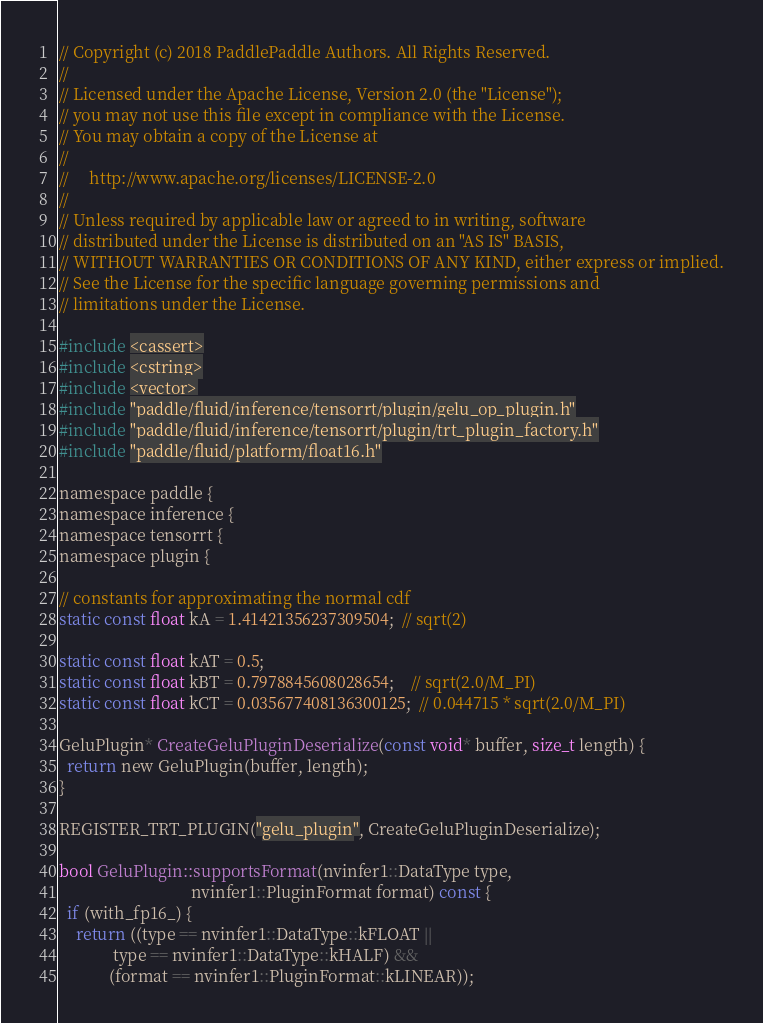Convert code to text. <code><loc_0><loc_0><loc_500><loc_500><_Cuda_>// Copyright (c) 2018 PaddlePaddle Authors. All Rights Reserved.
//
// Licensed under the Apache License, Version 2.0 (the "License");
// you may not use this file except in compliance with the License.
// You may obtain a copy of the License at
//
//     http://www.apache.org/licenses/LICENSE-2.0
//
// Unless required by applicable law or agreed to in writing, software
// distributed under the License is distributed on an "AS IS" BASIS,
// WITHOUT WARRANTIES OR CONDITIONS OF ANY KIND, either express or implied.
// See the License for the specific language governing permissions and
// limitations under the License.

#include <cassert>
#include <cstring>
#include <vector>
#include "paddle/fluid/inference/tensorrt/plugin/gelu_op_plugin.h"
#include "paddle/fluid/inference/tensorrt/plugin/trt_plugin_factory.h"
#include "paddle/fluid/platform/float16.h"

namespace paddle {
namespace inference {
namespace tensorrt {
namespace plugin {

// constants for approximating the normal cdf
static const float kA = 1.41421356237309504;  // sqrt(2)

static const float kAT = 0.5;
static const float kBT = 0.7978845608028654;    // sqrt(2.0/M_PI)
static const float kCT = 0.035677408136300125;  // 0.044715 * sqrt(2.0/M_PI)

GeluPlugin* CreateGeluPluginDeserialize(const void* buffer, size_t length) {
  return new GeluPlugin(buffer, length);
}

REGISTER_TRT_PLUGIN("gelu_plugin", CreateGeluPluginDeserialize);

bool GeluPlugin::supportsFormat(nvinfer1::DataType type,
                                nvinfer1::PluginFormat format) const {
  if (with_fp16_) {
    return ((type == nvinfer1::DataType::kFLOAT ||
             type == nvinfer1::DataType::kHALF) &&
            (format == nvinfer1::PluginFormat::kLINEAR));</code> 